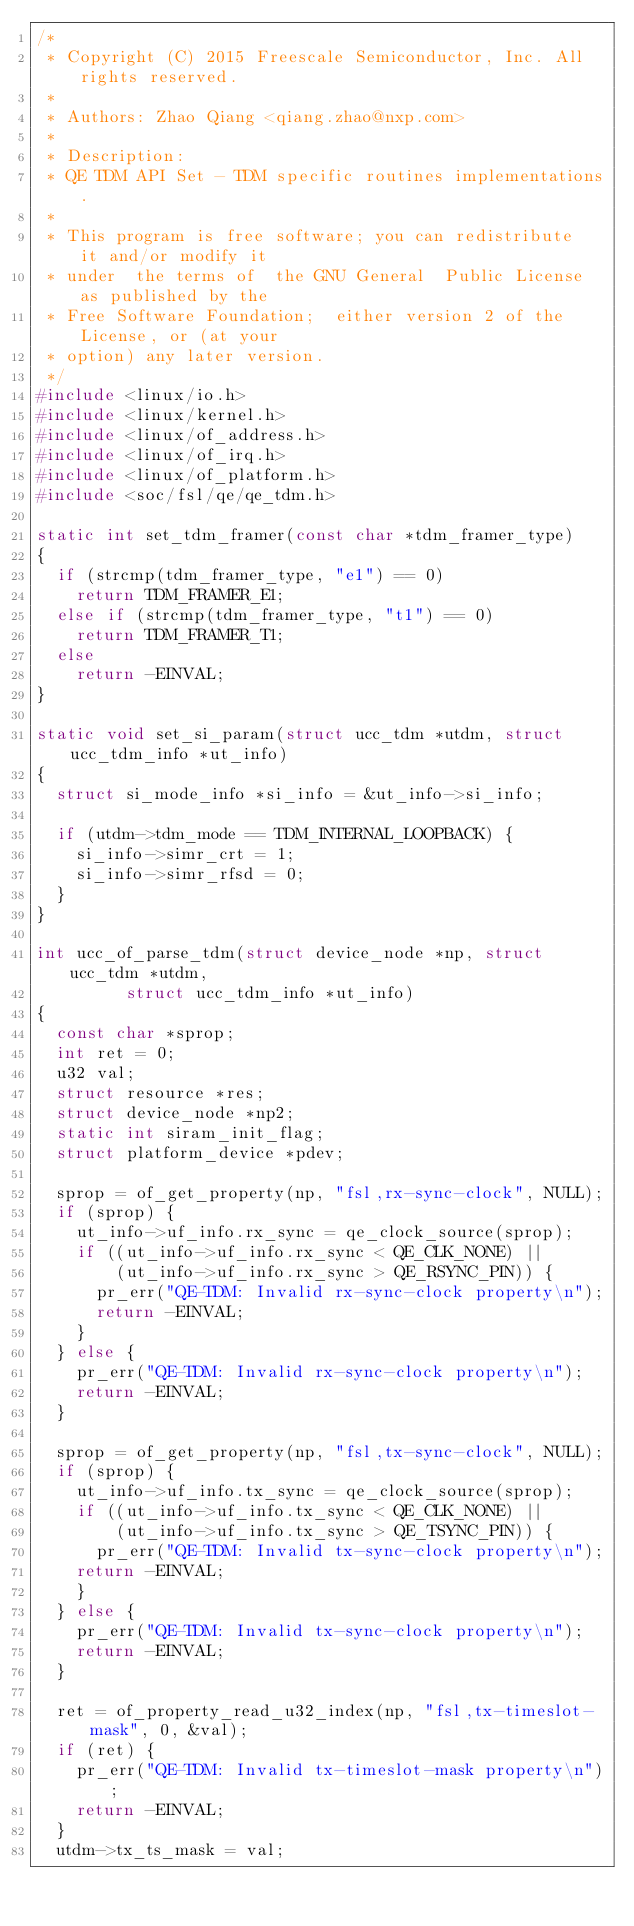<code> <loc_0><loc_0><loc_500><loc_500><_C_>/*
 * Copyright (C) 2015 Freescale Semiconductor, Inc. All rights reserved.
 *
 * Authors:	Zhao Qiang <qiang.zhao@nxp.com>
 *
 * Description:
 * QE TDM API Set - TDM specific routines implementations.
 *
 * This program is free software; you can redistribute  it and/or modify it
 * under  the terms of  the GNU General  Public License as published by the
 * Free Software Foundation;  either version 2 of the  License, or (at your
 * option) any later version.
 */
#include <linux/io.h>
#include <linux/kernel.h>
#include <linux/of_address.h>
#include <linux/of_irq.h>
#include <linux/of_platform.h>
#include <soc/fsl/qe/qe_tdm.h>

static int set_tdm_framer(const char *tdm_framer_type)
{
	if (strcmp(tdm_framer_type, "e1") == 0)
		return TDM_FRAMER_E1;
	else if (strcmp(tdm_framer_type, "t1") == 0)
		return TDM_FRAMER_T1;
	else
		return -EINVAL;
}

static void set_si_param(struct ucc_tdm *utdm, struct ucc_tdm_info *ut_info)
{
	struct si_mode_info *si_info = &ut_info->si_info;

	if (utdm->tdm_mode == TDM_INTERNAL_LOOPBACK) {
		si_info->simr_crt = 1;
		si_info->simr_rfsd = 0;
	}
}

int ucc_of_parse_tdm(struct device_node *np, struct ucc_tdm *utdm,
		     struct ucc_tdm_info *ut_info)
{
	const char *sprop;
	int ret = 0;
	u32 val;
	struct resource *res;
	struct device_node *np2;
	static int siram_init_flag;
	struct platform_device *pdev;

	sprop = of_get_property(np, "fsl,rx-sync-clock", NULL);
	if (sprop) {
		ut_info->uf_info.rx_sync = qe_clock_source(sprop);
		if ((ut_info->uf_info.rx_sync < QE_CLK_NONE) ||
		    (ut_info->uf_info.rx_sync > QE_RSYNC_PIN)) {
			pr_err("QE-TDM: Invalid rx-sync-clock property\n");
			return -EINVAL;
		}
	} else {
		pr_err("QE-TDM: Invalid rx-sync-clock property\n");
		return -EINVAL;
	}

	sprop = of_get_property(np, "fsl,tx-sync-clock", NULL);
	if (sprop) {
		ut_info->uf_info.tx_sync = qe_clock_source(sprop);
		if ((ut_info->uf_info.tx_sync < QE_CLK_NONE) ||
		    (ut_info->uf_info.tx_sync > QE_TSYNC_PIN)) {
			pr_err("QE-TDM: Invalid tx-sync-clock property\n");
		return -EINVAL;
		}
	} else {
		pr_err("QE-TDM: Invalid tx-sync-clock property\n");
		return -EINVAL;
	}

	ret = of_property_read_u32_index(np, "fsl,tx-timeslot-mask", 0, &val);
	if (ret) {
		pr_err("QE-TDM: Invalid tx-timeslot-mask property\n");
		return -EINVAL;
	}
	utdm->tx_ts_mask = val;
</code> 